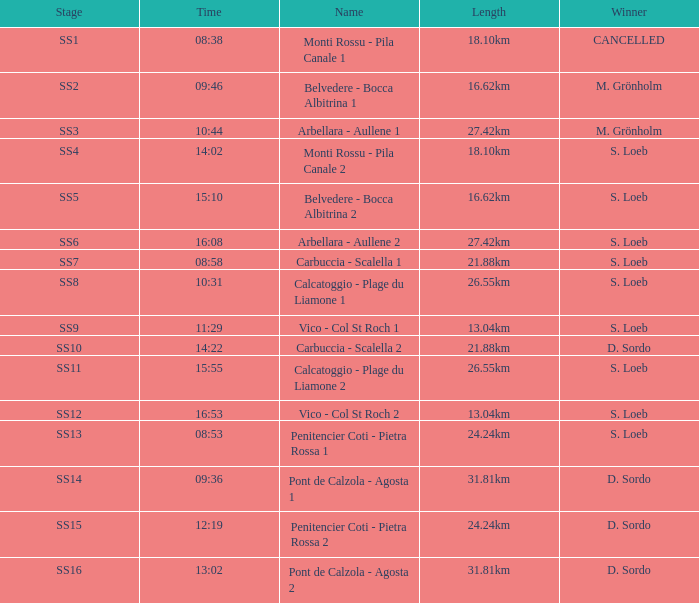What is the Name of the stage with S. Loeb as the Winner with a Length of 13.04km and a Stage of SS12? Vico - Col St Roch 2. 